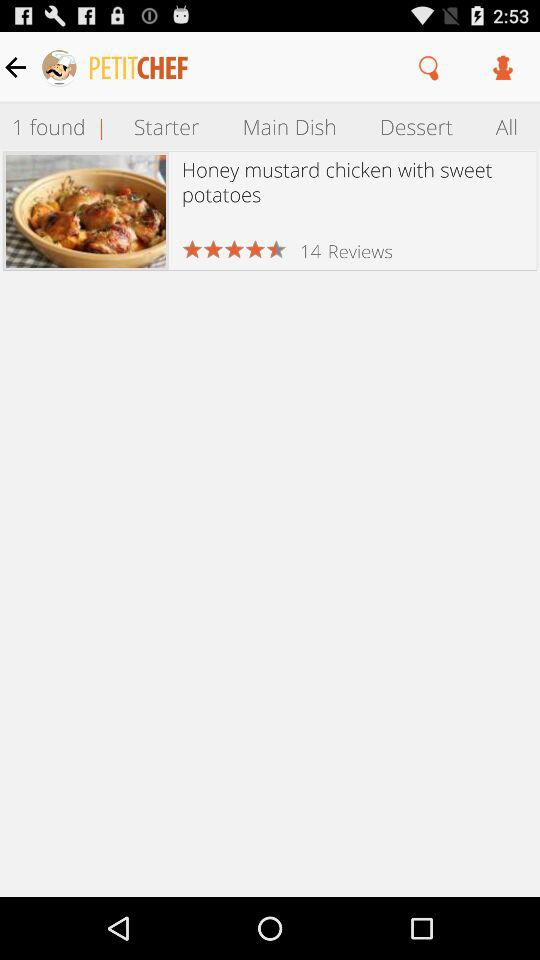What is the name of the application? The name of the application is "PETITCHEF". 